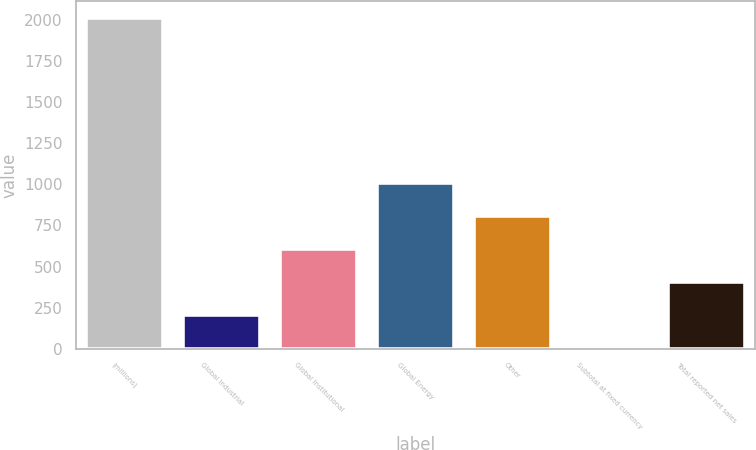<chart> <loc_0><loc_0><loc_500><loc_500><bar_chart><fcel>(millions)<fcel>Global Industrial<fcel>Global Institutional<fcel>Global Energy<fcel>Other<fcel>Subtotal at fixed currency<fcel>Total reported net sales<nl><fcel>2016<fcel>202.12<fcel>605.2<fcel>1008.28<fcel>806.74<fcel>0.58<fcel>403.66<nl></chart> 